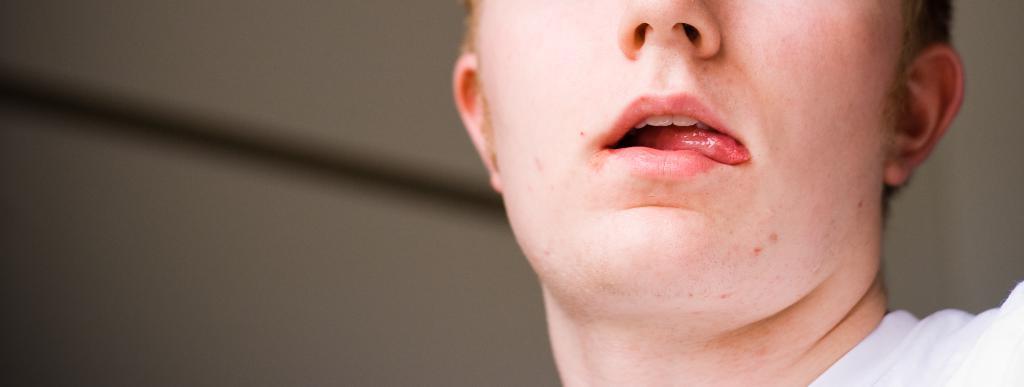Please provide a concise description of this image. In this image, we can see a person and the background. 